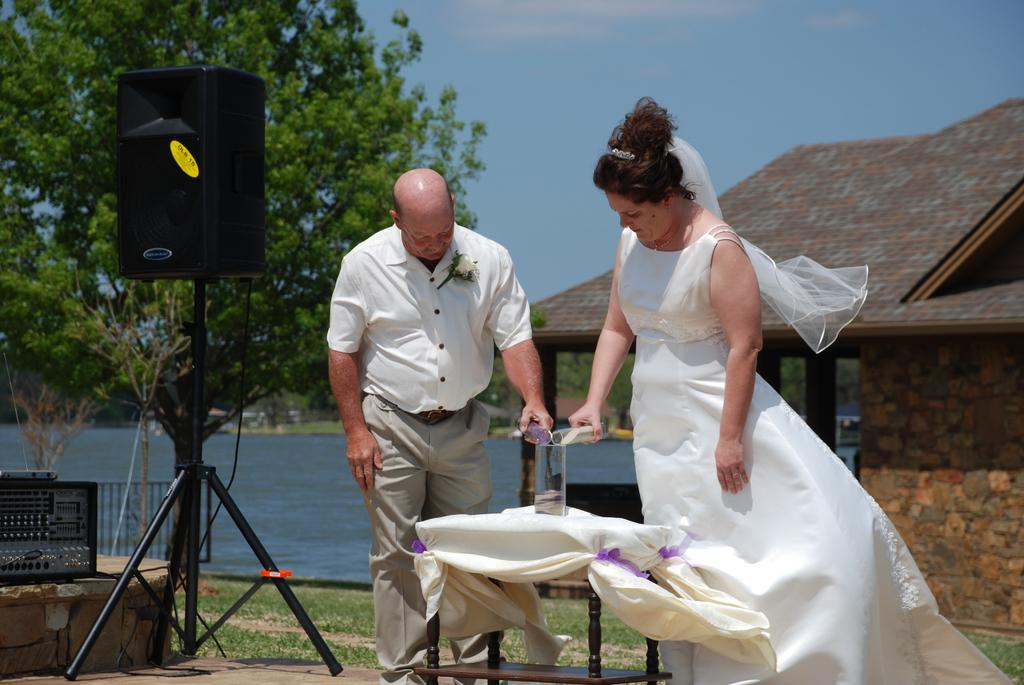How many people are in the image? There is a woman and a man in the image. What are the man and woman doing in the image? The man and woman are standing in the image. What can be seen in the background of the image? There is a speaker, a tree, and a house in the background of the image. What are the man and woman holding in the image? The man and woman are holding glasses in the image. Can you see a receipt in the man's hand in the image? There is no receipt visible in the man's hand in the image. What type of substance is dripping from the woman's fang in the image? There are no fangs or substances present in the image; the woman is holding a glass. 